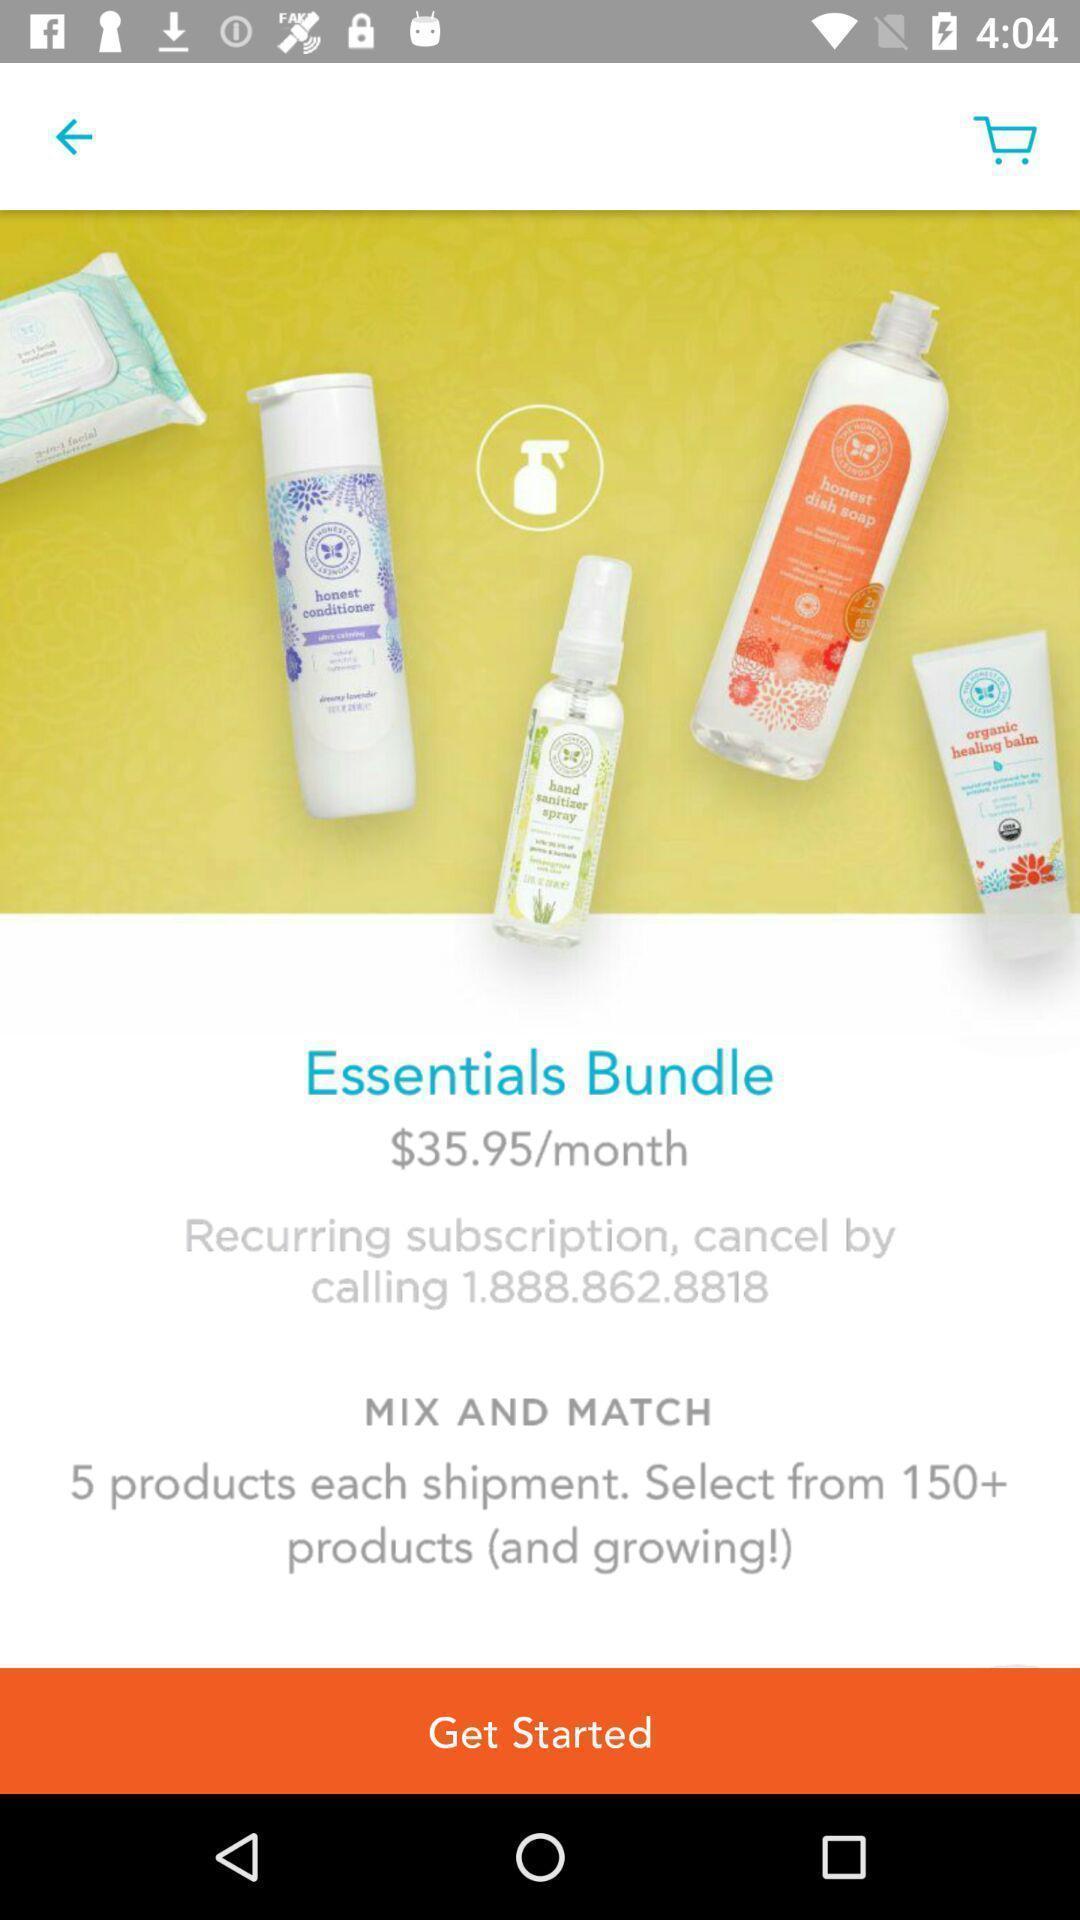What is the overall content of this screenshot? Welcome page of a shopping app. 